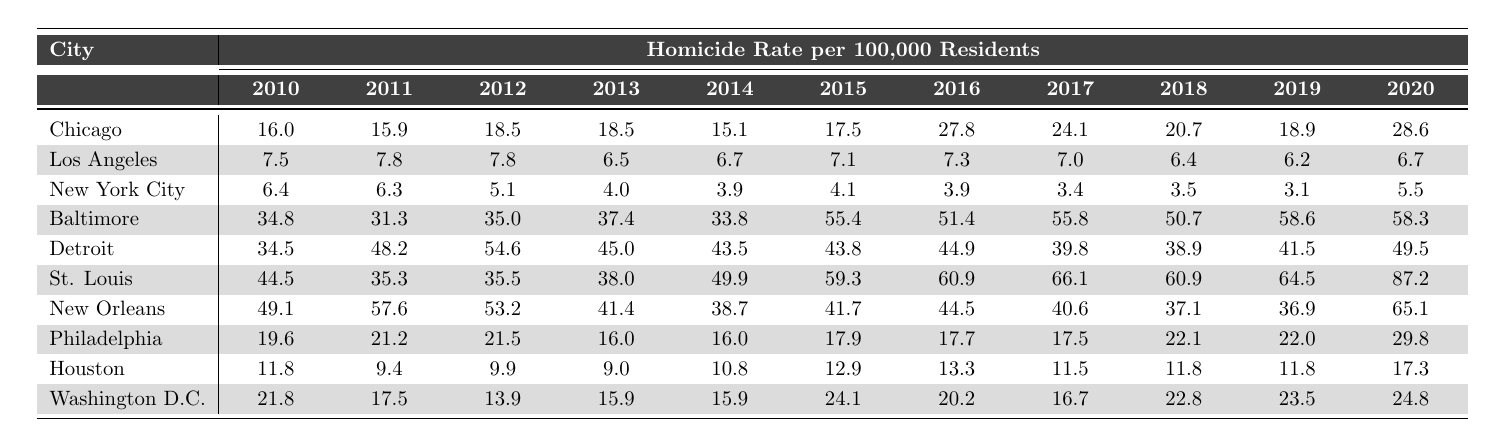What city had the highest homicide rate in 2020? By looking at the last column of the table for 2020, St. Louis has the highest value of 87.2 among all listed cities.
Answer: St. Louis Which city had the lowest homicide rate in 2010? In the first column for 2010, New York City has the lowest number at 6.4.
Answer: New York City What was the homicide rate in Baltimore in 2015? By referring to the row for Baltimore in the 2015 column, the homicide rate is noted as 55.4.
Answer: 55.4 Which city reduced its homicide rate the most from 2010 to 2015? Calculating the difference for each city from 2010 to 2015, Philadelphia's rate dropped from 19.6 to 17.9, a decrease of 1.7, indicating it had the least reduction.
Answer: Philadelphia In which year did Chicago experience the highest homicide rate? In reviewing the data for Chicago, the highest rate shown is 27.8 in 2016.
Answer: 2016 What was the average homicide rate for Los Angeles from 2010 to 2020? The rates for Los Angeles from 2010 to 2020 are summed as (7.5 + 7.8 + 7.8 + 6.5 + 6.7 + 7.1 + 7.3 + 7.0 + 6.4 + 6.2 + 6.7) = 68.6, and then divided by 11, yielding an average of 6.24.
Answer: 6.24 Did the homicide rate in New Orleans ever drop below 40 between 2010 and 2020? Reviewing the data for New Orleans, the rate was below 40 only in 2013 with a value of 41.4, indicating it did not drop below 40 any year.
Answer: No Which city had the most consistent homicide rate from 2010 to 2020? By analyzing the data range, Los Angeles had the least fluctuation in rates, maintaining values mostly between 6.4 and 7.8, signifying consistency.
Answer: Los Angeles What was the increase in homicide rate for Detroit from 2010 to 2020? The 2010 rate for Detroit was 34.5, increasing to 49.5 in 2020, resulting in a total increase of 15.0.
Answer: 15.0 Which three cities had the highest homicide rates in 2015? By checking the 2015 column, St. Louis (59.3), Baltimore (55.4), and Detroit (43.8) are identified as the top three cities with the highest homicide rates.
Answer: St. Louis, Baltimore, Detroit 